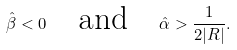<formula> <loc_0><loc_0><loc_500><loc_500>\hat { \beta } < 0 \quad \text {and} \quad \hat { \alpha } > \frac { 1 } { 2 | R | } .</formula> 